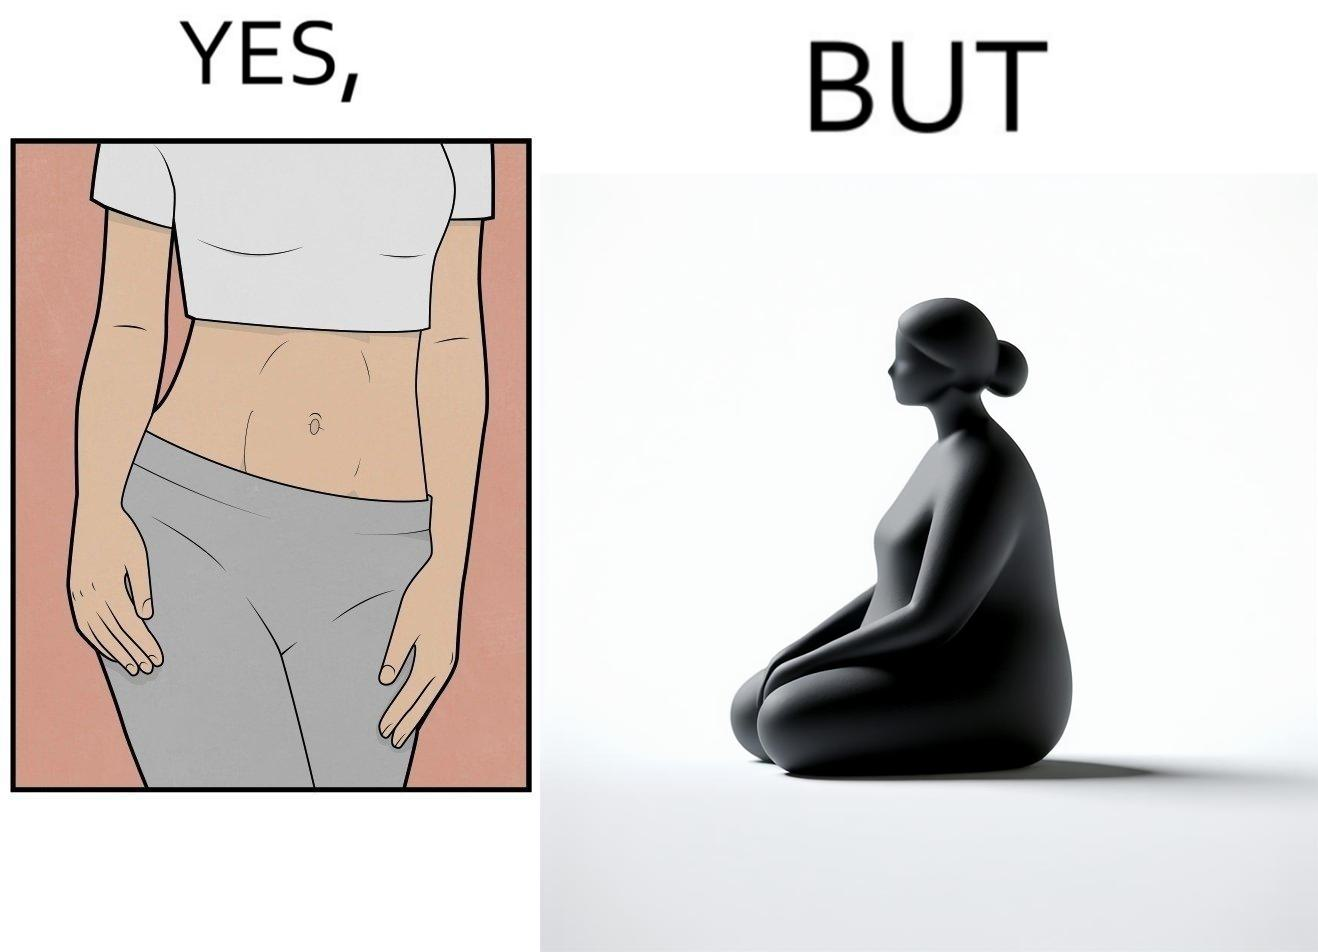What is shown in this image? the image is funny, as from the front, the woman is apparently slim, but she looks chubby from the side. 